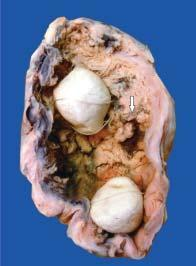does semisolid aspirates contain irregular, friable papillary growth arising from mucosa arrow?
Answer the question using a single word or phrase. No 